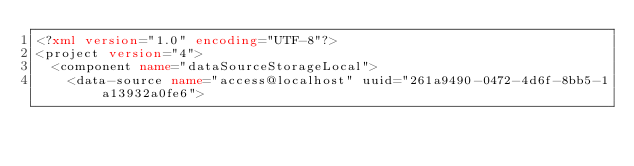<code> <loc_0><loc_0><loc_500><loc_500><_XML_><?xml version="1.0" encoding="UTF-8"?>
<project version="4">
  <component name="dataSourceStorageLocal">
    <data-source name="access@localhost" uuid="261a9490-0472-4d6f-8bb5-1a13932a0fe6"></code> 